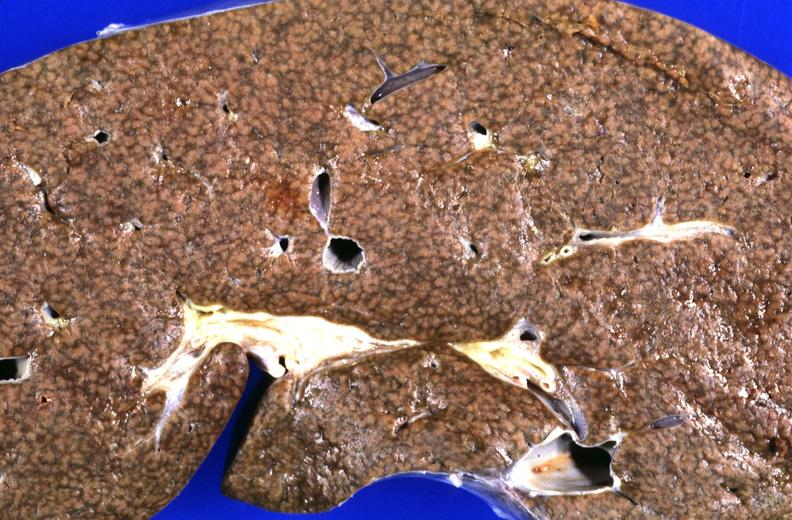s hepatobiliary present?
Answer the question using a single word or phrase. Yes 